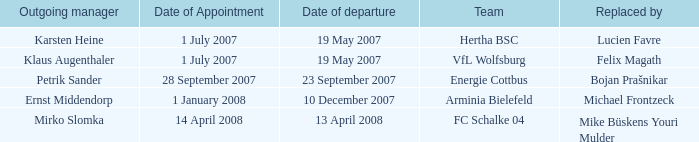When was the appointment date for the manager replaced by Lucien Favre? 1 July 2007. 